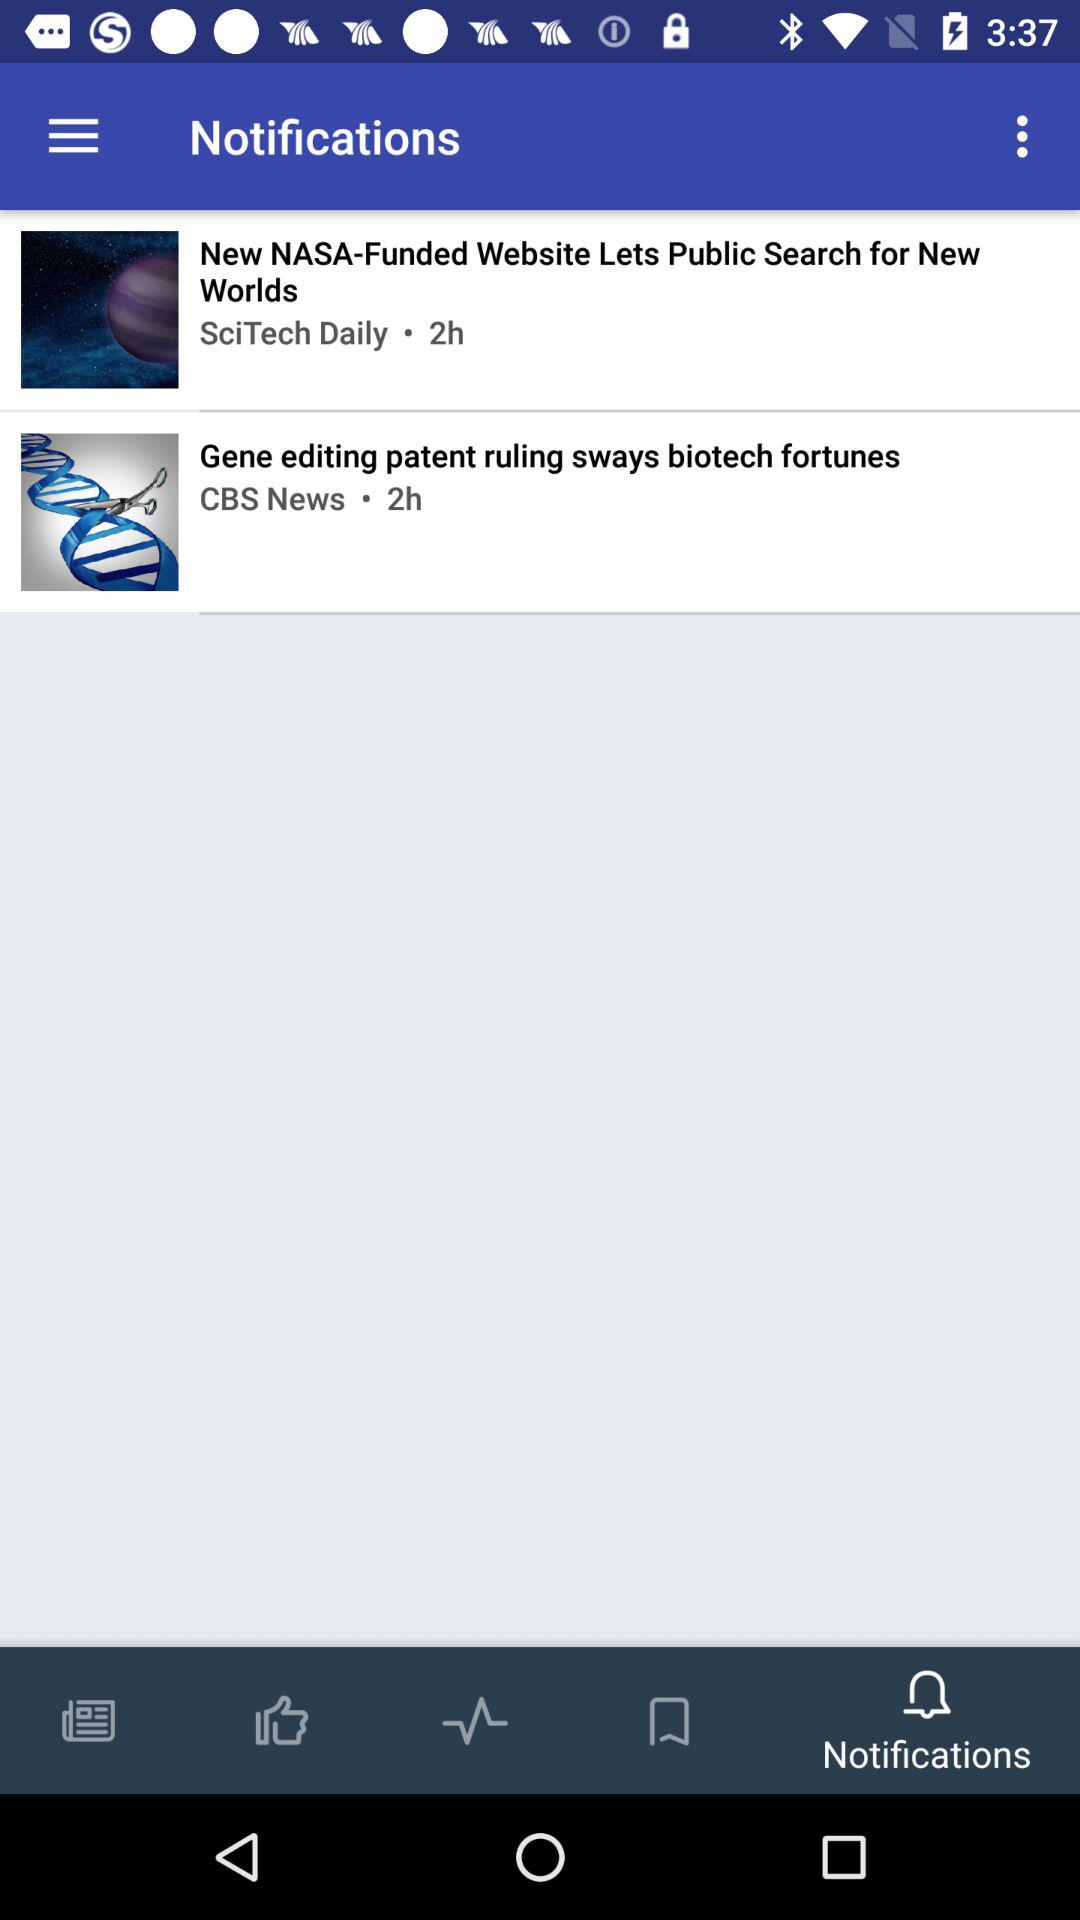How many items have a timestamp?
Answer the question using a single word or phrase. 2 